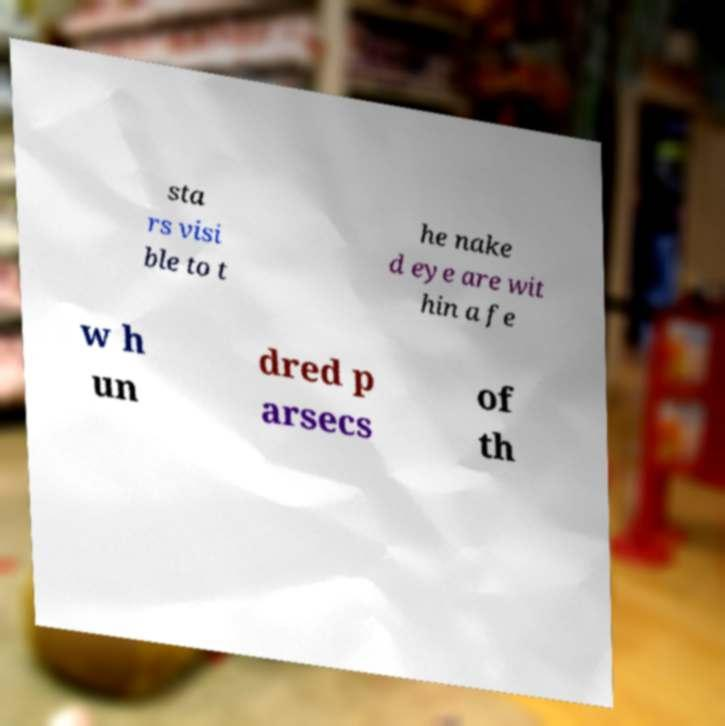What messages or text are displayed in this image? I need them in a readable, typed format. sta rs visi ble to t he nake d eye are wit hin a fe w h un dred p arsecs of th 